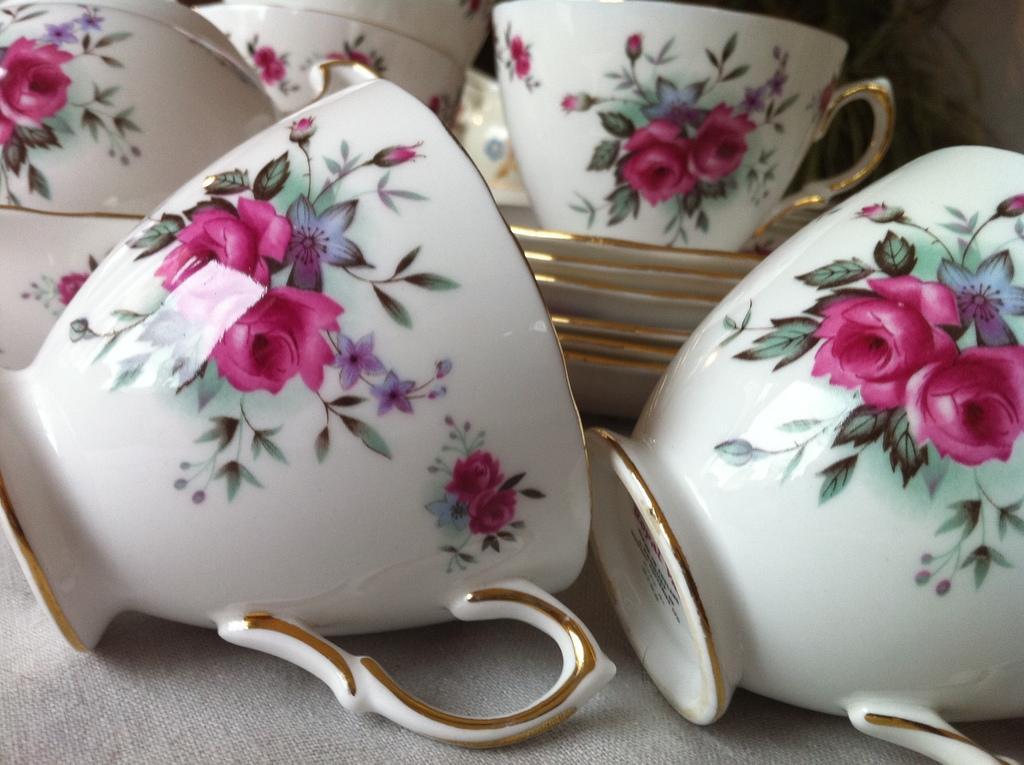Describe this image in one or two sentences. There are cups and saucers. On that there is a design of flowers, leaves and buds. 